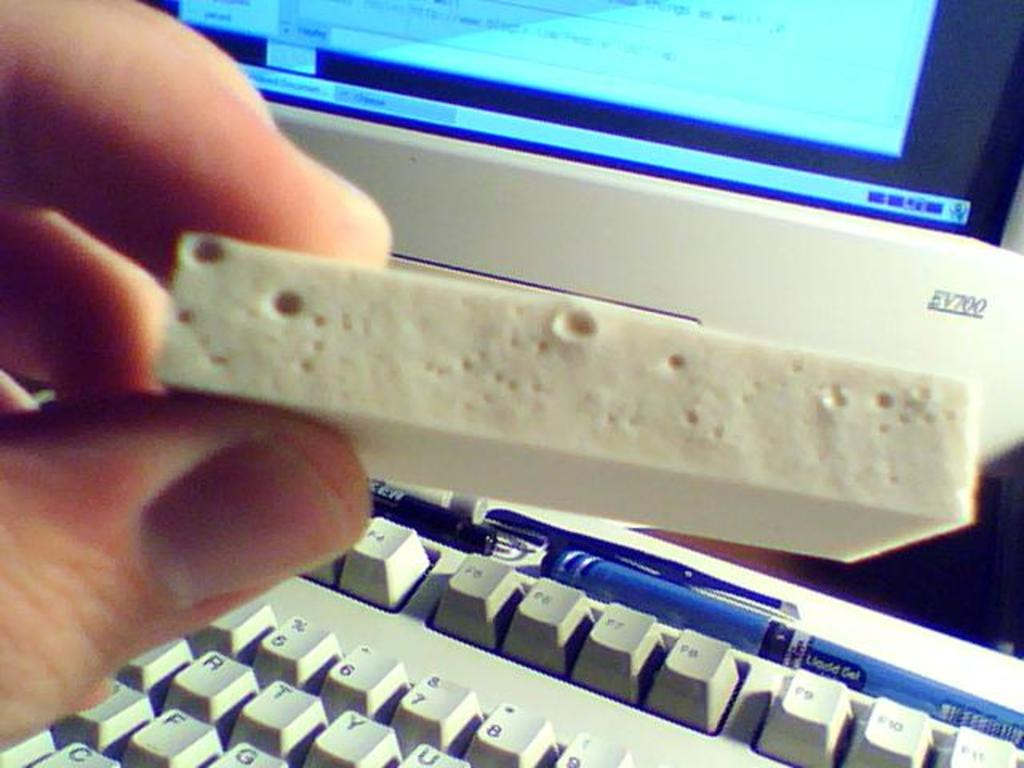Provide a one-sentence caption for the provided image. the monitor behind the man's hand has model number EV700. 